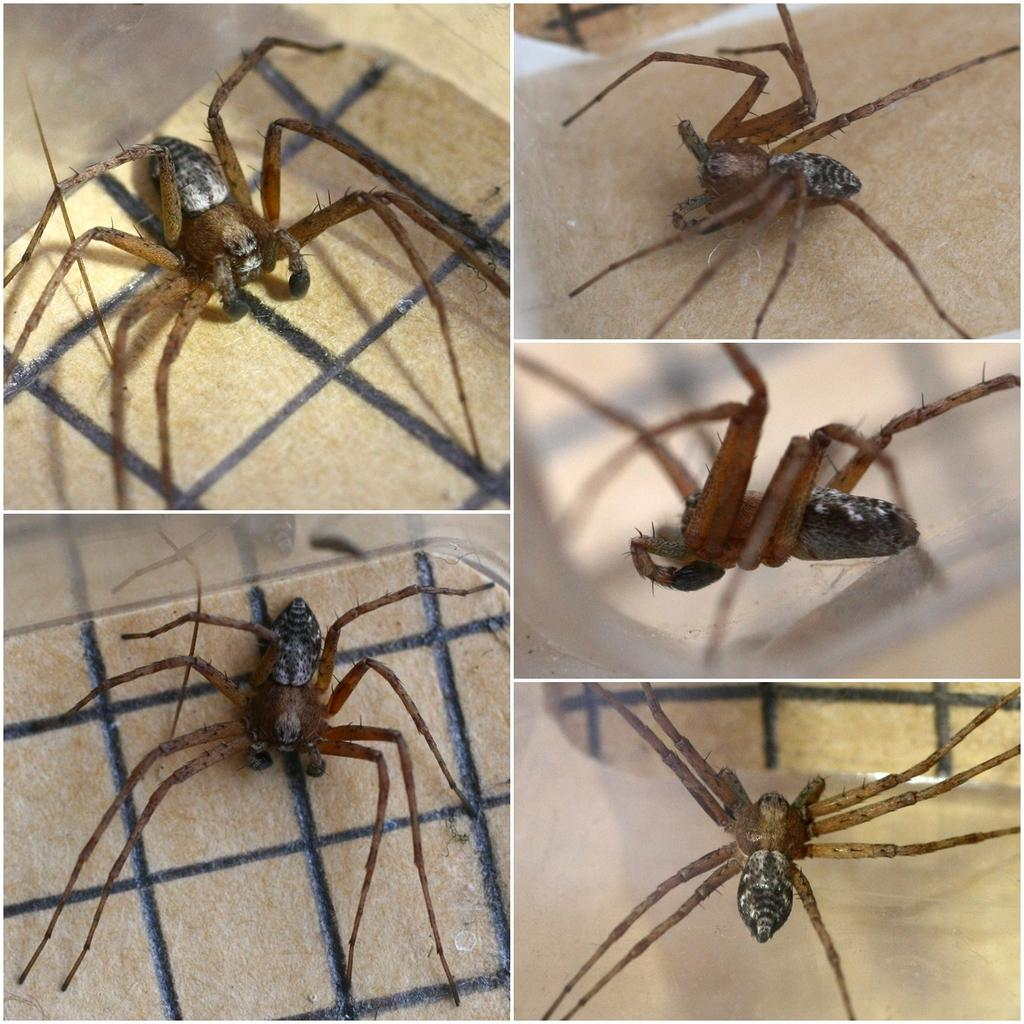What type of image is shown in the picture? The image is a collage edited image. How many images are included in the collage? There are five images in the collage. What is a common element in each image? Each image contains a spider. Where is the spider located in each image? The spider is on an object in each image. Can you see the ocean in any of the images? No, there is no ocean visible in any of the images, as each image contains a spider on an object. Is there a crook present in any of the images? No, there is no crook present in any of the images; each image features a spider on an object. 